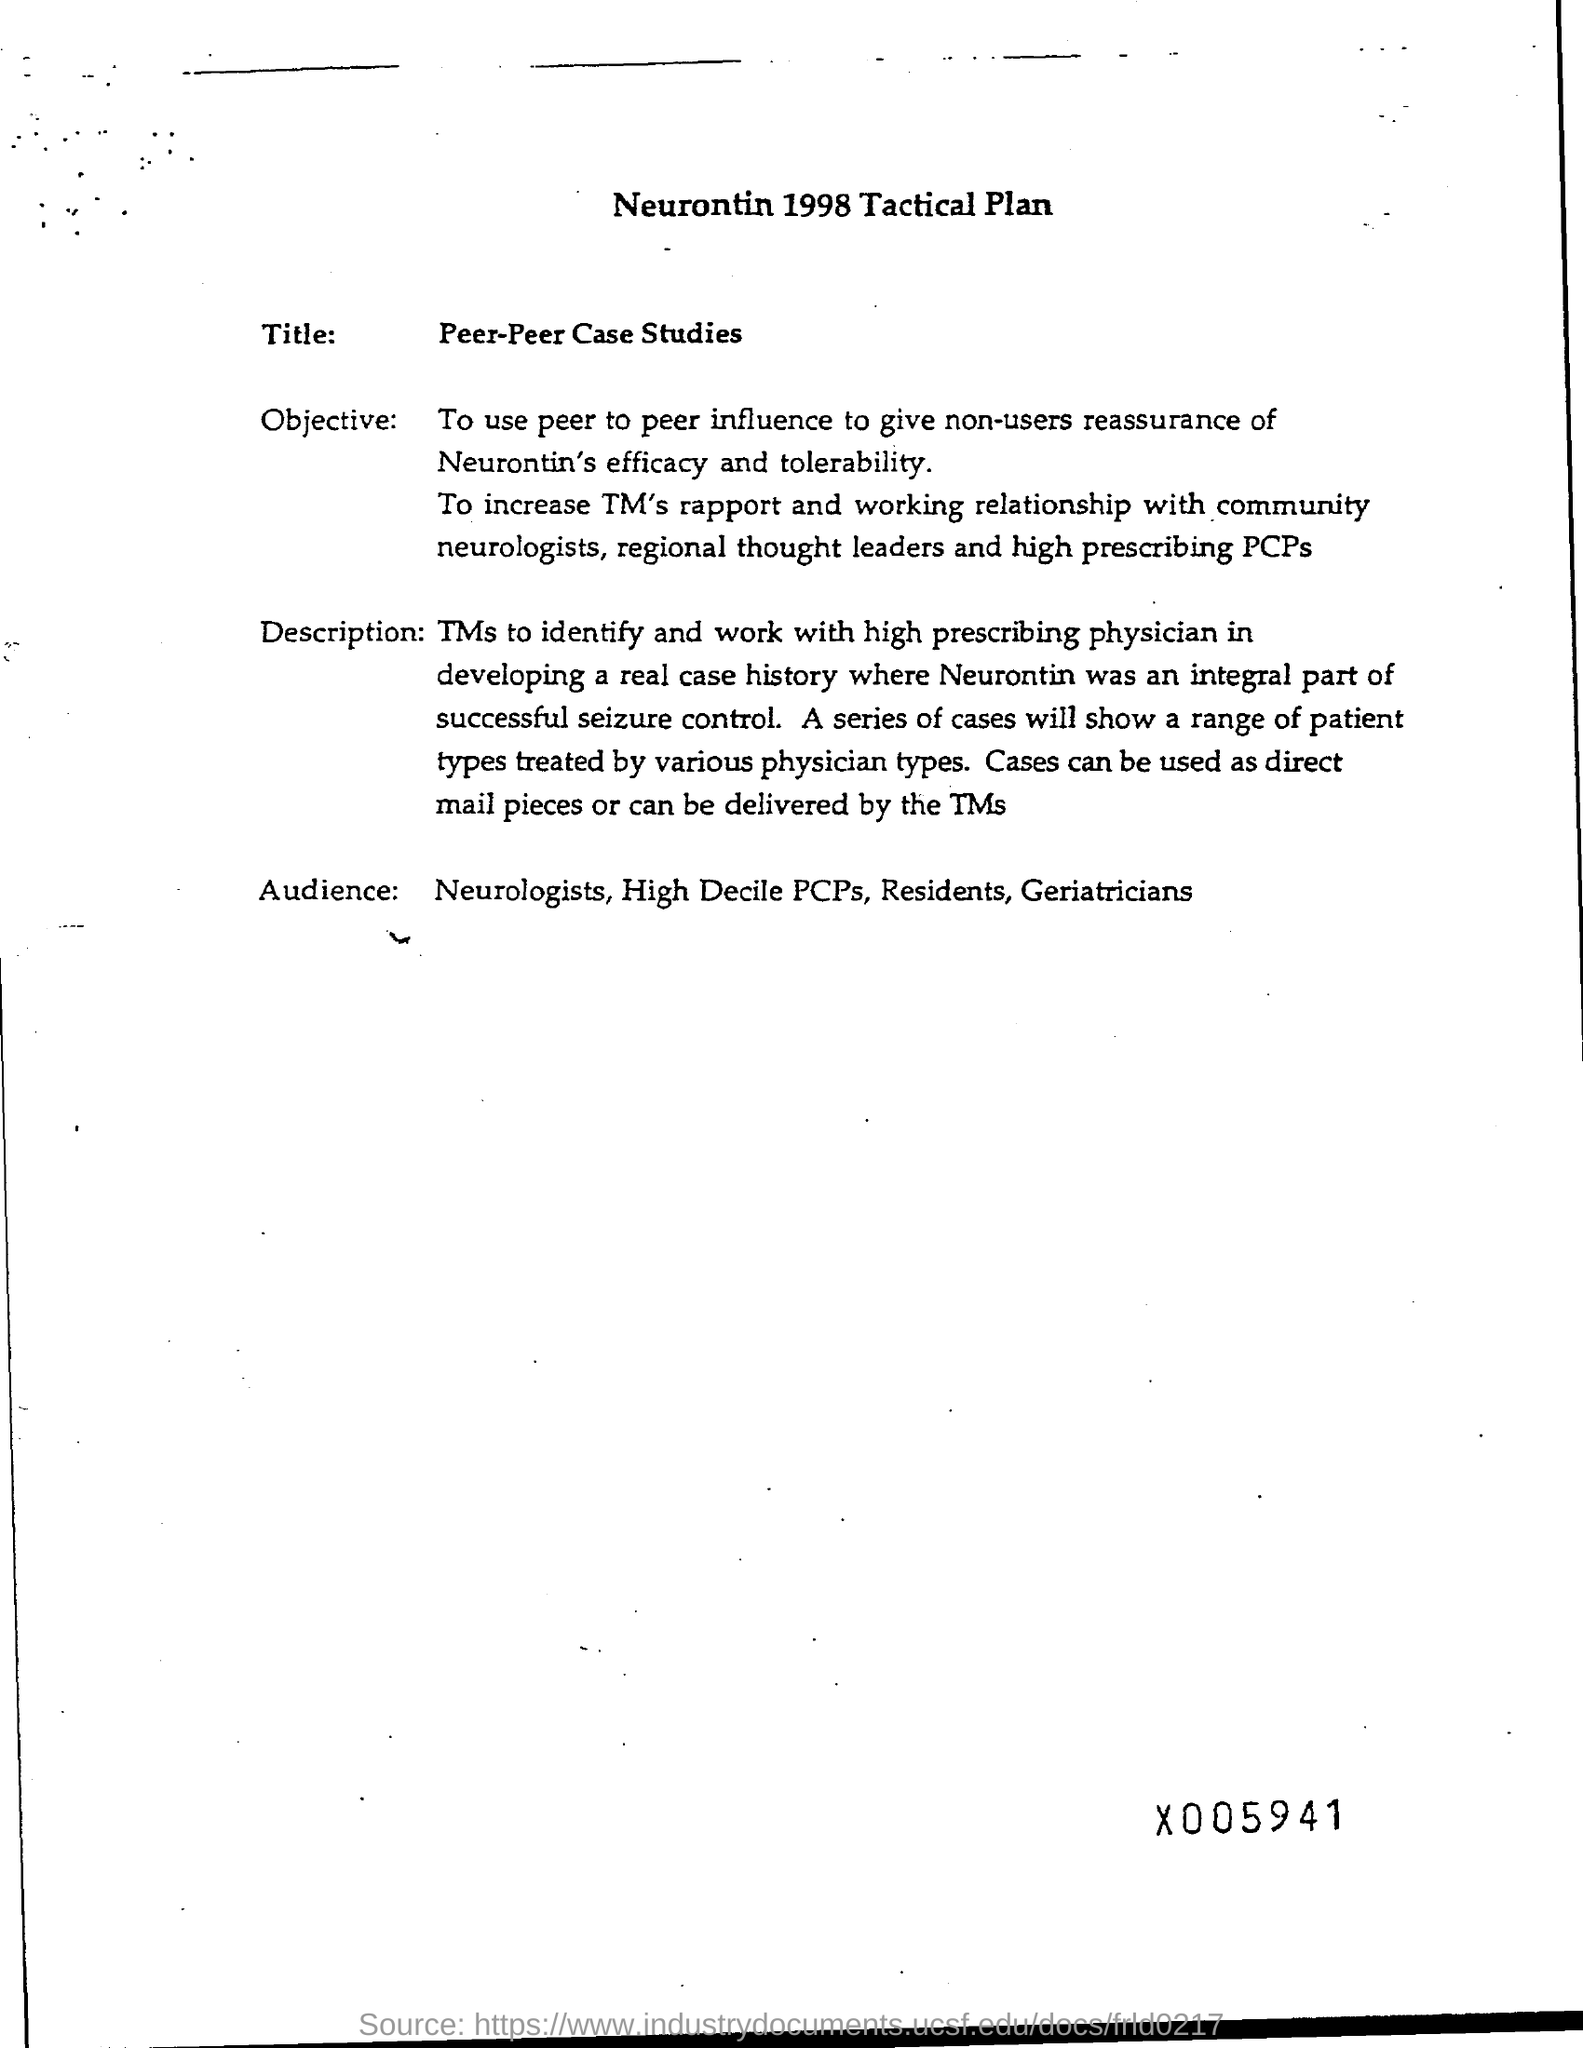What is the Title of the document?
Ensure brevity in your answer.  Neurontin 1998 Tactical Plan. What is the Title?
Provide a short and direct response. Peer-Peer Case Studies. 